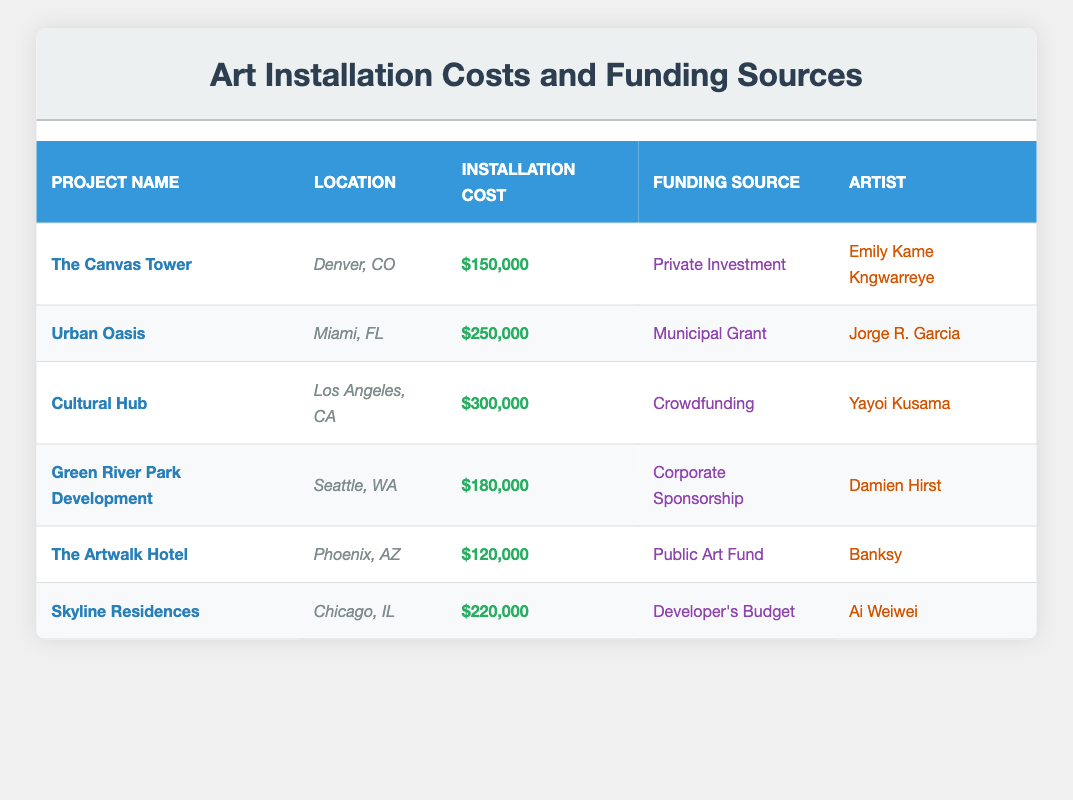What is the installation cost of "The Artwalk Hotel"? The table shows that "The Artwalk Hotel" has an installation cost listed in the corresponding row. The value is $120,000.
Answer: $120,000 Which funding source is used for the "Cultural Hub" project? Looking at the row for "Cultural Hub," the funding source is specified as "Crowdfunding."
Answer: Crowdfunding What is the total installation cost of all projects? To find the total, we need to sum the installation costs: 150000 + 250000 + 300000 + 180000 + 120000 + 220000 = 1220000.
Answer: $1,220,000 Does "Green River Park Development" have a higher installation cost than "Skyline Residences"? The installation cost for "Green River Park Development" is $180,000, while for "Skyline Residences," it’s $220,000. Since 180,000 is less than 220,000, the statement is false.
Answer: No What is the average installation cost of all the projects? First, we sum the installation costs: 150000 + 250000 + 300000 + 180000 + 120000 + 220000 = 1220000. Then, there are 6 projects, so the average cost is 1220000 / 6 = 203333.33.
Answer: $203,333.33 